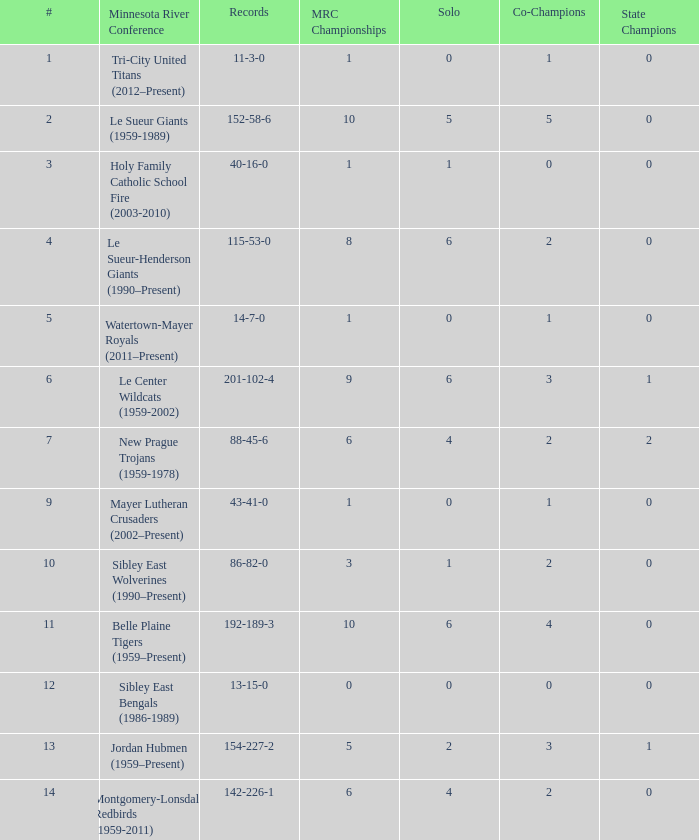How many teams are #2 on the list? 1.0. 